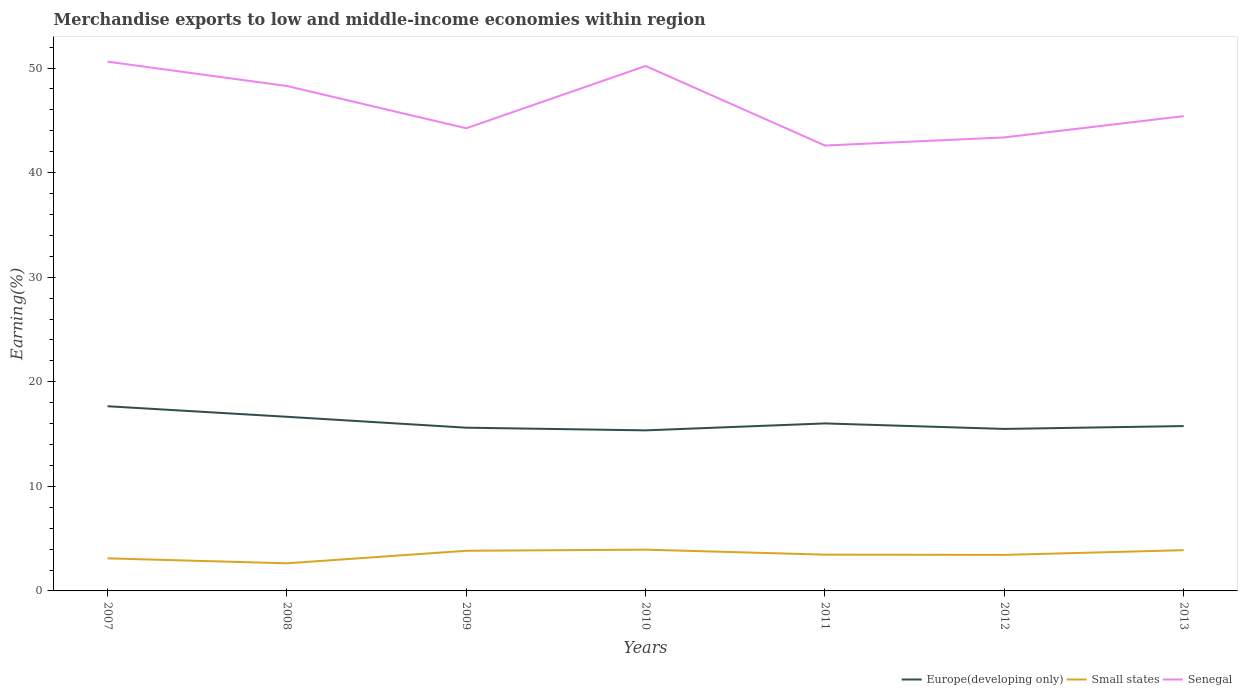How many different coloured lines are there?
Offer a very short reply. 3. Is the number of lines equal to the number of legend labels?
Your answer should be very brief. Yes. Across all years, what is the maximum percentage of amount earned from merchandise exports in Europe(developing only)?
Your answer should be very brief. 15.35. What is the total percentage of amount earned from merchandise exports in Senegal in the graph?
Offer a very short reply. 2.33. What is the difference between the highest and the second highest percentage of amount earned from merchandise exports in Europe(developing only)?
Offer a very short reply. 2.31. What is the difference between the highest and the lowest percentage of amount earned from merchandise exports in Small states?
Provide a succinct answer. 3. Is the percentage of amount earned from merchandise exports in Small states strictly greater than the percentage of amount earned from merchandise exports in Europe(developing only) over the years?
Give a very brief answer. Yes. How many lines are there?
Give a very brief answer. 3. How many years are there in the graph?
Provide a succinct answer. 7. Are the values on the major ticks of Y-axis written in scientific E-notation?
Provide a short and direct response. No. How many legend labels are there?
Give a very brief answer. 3. What is the title of the graph?
Your answer should be very brief. Merchandise exports to low and middle-income economies within region. What is the label or title of the X-axis?
Your answer should be compact. Years. What is the label or title of the Y-axis?
Make the answer very short. Earning(%). What is the Earning(%) in Europe(developing only) in 2007?
Your answer should be very brief. 17.66. What is the Earning(%) in Small states in 2007?
Ensure brevity in your answer.  3.12. What is the Earning(%) in Senegal in 2007?
Your answer should be compact. 50.61. What is the Earning(%) in Europe(developing only) in 2008?
Your response must be concise. 16.65. What is the Earning(%) of Small states in 2008?
Make the answer very short. 2.64. What is the Earning(%) in Senegal in 2008?
Your answer should be compact. 48.29. What is the Earning(%) of Europe(developing only) in 2009?
Your answer should be compact. 15.61. What is the Earning(%) of Small states in 2009?
Make the answer very short. 3.84. What is the Earning(%) of Senegal in 2009?
Ensure brevity in your answer.  44.24. What is the Earning(%) of Europe(developing only) in 2010?
Ensure brevity in your answer.  15.35. What is the Earning(%) of Small states in 2010?
Give a very brief answer. 3.95. What is the Earning(%) in Senegal in 2010?
Give a very brief answer. 50.2. What is the Earning(%) in Europe(developing only) in 2011?
Offer a terse response. 16.02. What is the Earning(%) in Small states in 2011?
Give a very brief answer. 3.47. What is the Earning(%) of Senegal in 2011?
Your answer should be very brief. 42.59. What is the Earning(%) in Europe(developing only) in 2012?
Your answer should be compact. 15.49. What is the Earning(%) in Small states in 2012?
Offer a very short reply. 3.45. What is the Earning(%) of Senegal in 2012?
Your answer should be very brief. 43.37. What is the Earning(%) in Europe(developing only) in 2013?
Your answer should be very brief. 15.77. What is the Earning(%) in Small states in 2013?
Ensure brevity in your answer.  3.9. What is the Earning(%) in Senegal in 2013?
Your response must be concise. 45.4. Across all years, what is the maximum Earning(%) of Europe(developing only)?
Keep it short and to the point. 17.66. Across all years, what is the maximum Earning(%) of Small states?
Provide a short and direct response. 3.95. Across all years, what is the maximum Earning(%) of Senegal?
Ensure brevity in your answer.  50.61. Across all years, what is the minimum Earning(%) in Europe(developing only)?
Your answer should be compact. 15.35. Across all years, what is the minimum Earning(%) of Small states?
Offer a terse response. 2.64. Across all years, what is the minimum Earning(%) in Senegal?
Your response must be concise. 42.59. What is the total Earning(%) in Europe(developing only) in the graph?
Provide a succinct answer. 112.55. What is the total Earning(%) of Small states in the graph?
Your answer should be very brief. 24.35. What is the total Earning(%) of Senegal in the graph?
Provide a succinct answer. 324.71. What is the difference between the Earning(%) of Europe(developing only) in 2007 and that in 2008?
Ensure brevity in your answer.  1.01. What is the difference between the Earning(%) in Small states in 2007 and that in 2008?
Keep it short and to the point. 0.48. What is the difference between the Earning(%) of Senegal in 2007 and that in 2008?
Give a very brief answer. 2.33. What is the difference between the Earning(%) of Europe(developing only) in 2007 and that in 2009?
Offer a very short reply. 2.05. What is the difference between the Earning(%) in Small states in 2007 and that in 2009?
Your answer should be very brief. -0.72. What is the difference between the Earning(%) in Senegal in 2007 and that in 2009?
Provide a succinct answer. 6.37. What is the difference between the Earning(%) of Europe(developing only) in 2007 and that in 2010?
Make the answer very short. 2.31. What is the difference between the Earning(%) in Small states in 2007 and that in 2010?
Provide a short and direct response. -0.83. What is the difference between the Earning(%) of Senegal in 2007 and that in 2010?
Offer a very short reply. 0.41. What is the difference between the Earning(%) in Europe(developing only) in 2007 and that in 2011?
Offer a very short reply. 1.64. What is the difference between the Earning(%) in Small states in 2007 and that in 2011?
Provide a succinct answer. -0.35. What is the difference between the Earning(%) in Senegal in 2007 and that in 2011?
Your response must be concise. 8.02. What is the difference between the Earning(%) in Europe(developing only) in 2007 and that in 2012?
Your answer should be compact. 2.17. What is the difference between the Earning(%) of Small states in 2007 and that in 2012?
Offer a terse response. -0.33. What is the difference between the Earning(%) in Senegal in 2007 and that in 2012?
Ensure brevity in your answer.  7.24. What is the difference between the Earning(%) in Europe(developing only) in 2007 and that in 2013?
Offer a very short reply. 1.9. What is the difference between the Earning(%) of Small states in 2007 and that in 2013?
Keep it short and to the point. -0.78. What is the difference between the Earning(%) of Senegal in 2007 and that in 2013?
Your response must be concise. 5.21. What is the difference between the Earning(%) of Europe(developing only) in 2008 and that in 2009?
Offer a terse response. 1.04. What is the difference between the Earning(%) in Small states in 2008 and that in 2009?
Your response must be concise. -1.2. What is the difference between the Earning(%) in Senegal in 2008 and that in 2009?
Provide a short and direct response. 4.04. What is the difference between the Earning(%) in Europe(developing only) in 2008 and that in 2010?
Your answer should be compact. 1.3. What is the difference between the Earning(%) in Small states in 2008 and that in 2010?
Keep it short and to the point. -1.31. What is the difference between the Earning(%) in Senegal in 2008 and that in 2010?
Your answer should be compact. -1.91. What is the difference between the Earning(%) of Europe(developing only) in 2008 and that in 2011?
Keep it short and to the point. 0.63. What is the difference between the Earning(%) in Small states in 2008 and that in 2011?
Your response must be concise. -0.83. What is the difference between the Earning(%) of Senegal in 2008 and that in 2011?
Give a very brief answer. 5.69. What is the difference between the Earning(%) of Europe(developing only) in 2008 and that in 2012?
Offer a terse response. 1.16. What is the difference between the Earning(%) in Small states in 2008 and that in 2012?
Provide a succinct answer. -0.81. What is the difference between the Earning(%) in Senegal in 2008 and that in 2012?
Make the answer very short. 4.92. What is the difference between the Earning(%) in Europe(developing only) in 2008 and that in 2013?
Your answer should be very brief. 0.89. What is the difference between the Earning(%) of Small states in 2008 and that in 2013?
Provide a succinct answer. -1.26. What is the difference between the Earning(%) in Senegal in 2008 and that in 2013?
Ensure brevity in your answer.  2.88. What is the difference between the Earning(%) in Europe(developing only) in 2009 and that in 2010?
Offer a very short reply. 0.26. What is the difference between the Earning(%) in Small states in 2009 and that in 2010?
Provide a short and direct response. -0.11. What is the difference between the Earning(%) in Senegal in 2009 and that in 2010?
Ensure brevity in your answer.  -5.96. What is the difference between the Earning(%) in Europe(developing only) in 2009 and that in 2011?
Make the answer very short. -0.41. What is the difference between the Earning(%) of Small states in 2009 and that in 2011?
Offer a very short reply. 0.37. What is the difference between the Earning(%) of Senegal in 2009 and that in 2011?
Give a very brief answer. 1.65. What is the difference between the Earning(%) in Europe(developing only) in 2009 and that in 2012?
Make the answer very short. 0.12. What is the difference between the Earning(%) in Small states in 2009 and that in 2012?
Your response must be concise. 0.39. What is the difference between the Earning(%) of Senegal in 2009 and that in 2012?
Offer a very short reply. 0.87. What is the difference between the Earning(%) of Europe(developing only) in 2009 and that in 2013?
Keep it short and to the point. -0.16. What is the difference between the Earning(%) in Small states in 2009 and that in 2013?
Offer a terse response. -0.06. What is the difference between the Earning(%) in Senegal in 2009 and that in 2013?
Give a very brief answer. -1.16. What is the difference between the Earning(%) of Europe(developing only) in 2010 and that in 2011?
Provide a short and direct response. -0.66. What is the difference between the Earning(%) in Small states in 2010 and that in 2011?
Provide a succinct answer. 0.48. What is the difference between the Earning(%) in Senegal in 2010 and that in 2011?
Keep it short and to the point. 7.61. What is the difference between the Earning(%) in Europe(developing only) in 2010 and that in 2012?
Provide a short and direct response. -0.14. What is the difference between the Earning(%) in Small states in 2010 and that in 2012?
Keep it short and to the point. 0.5. What is the difference between the Earning(%) of Senegal in 2010 and that in 2012?
Offer a terse response. 6.83. What is the difference between the Earning(%) in Europe(developing only) in 2010 and that in 2013?
Provide a short and direct response. -0.41. What is the difference between the Earning(%) in Small states in 2010 and that in 2013?
Ensure brevity in your answer.  0.05. What is the difference between the Earning(%) in Senegal in 2010 and that in 2013?
Give a very brief answer. 4.8. What is the difference between the Earning(%) of Europe(developing only) in 2011 and that in 2012?
Your answer should be compact. 0.53. What is the difference between the Earning(%) of Small states in 2011 and that in 2012?
Provide a succinct answer. 0.02. What is the difference between the Earning(%) of Senegal in 2011 and that in 2012?
Offer a terse response. -0.78. What is the difference between the Earning(%) in Europe(developing only) in 2011 and that in 2013?
Make the answer very short. 0.25. What is the difference between the Earning(%) of Small states in 2011 and that in 2013?
Give a very brief answer. -0.43. What is the difference between the Earning(%) in Senegal in 2011 and that in 2013?
Your response must be concise. -2.81. What is the difference between the Earning(%) of Europe(developing only) in 2012 and that in 2013?
Your answer should be compact. -0.27. What is the difference between the Earning(%) in Small states in 2012 and that in 2013?
Your answer should be very brief. -0.45. What is the difference between the Earning(%) in Senegal in 2012 and that in 2013?
Ensure brevity in your answer.  -2.03. What is the difference between the Earning(%) of Europe(developing only) in 2007 and the Earning(%) of Small states in 2008?
Provide a short and direct response. 15.02. What is the difference between the Earning(%) of Europe(developing only) in 2007 and the Earning(%) of Senegal in 2008?
Make the answer very short. -30.62. What is the difference between the Earning(%) of Small states in 2007 and the Earning(%) of Senegal in 2008?
Offer a very short reply. -45.17. What is the difference between the Earning(%) of Europe(developing only) in 2007 and the Earning(%) of Small states in 2009?
Keep it short and to the point. 13.82. What is the difference between the Earning(%) of Europe(developing only) in 2007 and the Earning(%) of Senegal in 2009?
Provide a succinct answer. -26.58. What is the difference between the Earning(%) in Small states in 2007 and the Earning(%) in Senegal in 2009?
Your answer should be very brief. -41.13. What is the difference between the Earning(%) of Europe(developing only) in 2007 and the Earning(%) of Small states in 2010?
Keep it short and to the point. 13.71. What is the difference between the Earning(%) in Europe(developing only) in 2007 and the Earning(%) in Senegal in 2010?
Ensure brevity in your answer.  -32.54. What is the difference between the Earning(%) of Small states in 2007 and the Earning(%) of Senegal in 2010?
Ensure brevity in your answer.  -47.08. What is the difference between the Earning(%) in Europe(developing only) in 2007 and the Earning(%) in Small states in 2011?
Offer a terse response. 14.19. What is the difference between the Earning(%) in Europe(developing only) in 2007 and the Earning(%) in Senegal in 2011?
Your answer should be very brief. -24.93. What is the difference between the Earning(%) of Small states in 2007 and the Earning(%) of Senegal in 2011?
Your answer should be very brief. -39.48. What is the difference between the Earning(%) in Europe(developing only) in 2007 and the Earning(%) in Small states in 2012?
Provide a short and direct response. 14.21. What is the difference between the Earning(%) of Europe(developing only) in 2007 and the Earning(%) of Senegal in 2012?
Ensure brevity in your answer.  -25.71. What is the difference between the Earning(%) in Small states in 2007 and the Earning(%) in Senegal in 2012?
Give a very brief answer. -40.25. What is the difference between the Earning(%) in Europe(developing only) in 2007 and the Earning(%) in Small states in 2013?
Your answer should be very brief. 13.76. What is the difference between the Earning(%) of Europe(developing only) in 2007 and the Earning(%) of Senegal in 2013?
Offer a terse response. -27.74. What is the difference between the Earning(%) of Small states in 2007 and the Earning(%) of Senegal in 2013?
Ensure brevity in your answer.  -42.29. What is the difference between the Earning(%) in Europe(developing only) in 2008 and the Earning(%) in Small states in 2009?
Your response must be concise. 12.81. What is the difference between the Earning(%) of Europe(developing only) in 2008 and the Earning(%) of Senegal in 2009?
Offer a terse response. -27.59. What is the difference between the Earning(%) in Small states in 2008 and the Earning(%) in Senegal in 2009?
Provide a succinct answer. -41.6. What is the difference between the Earning(%) in Europe(developing only) in 2008 and the Earning(%) in Small states in 2010?
Your response must be concise. 12.71. What is the difference between the Earning(%) of Europe(developing only) in 2008 and the Earning(%) of Senegal in 2010?
Make the answer very short. -33.55. What is the difference between the Earning(%) in Small states in 2008 and the Earning(%) in Senegal in 2010?
Provide a short and direct response. -47.56. What is the difference between the Earning(%) in Europe(developing only) in 2008 and the Earning(%) in Small states in 2011?
Keep it short and to the point. 13.18. What is the difference between the Earning(%) in Europe(developing only) in 2008 and the Earning(%) in Senegal in 2011?
Offer a terse response. -25.94. What is the difference between the Earning(%) in Small states in 2008 and the Earning(%) in Senegal in 2011?
Offer a very short reply. -39.95. What is the difference between the Earning(%) in Europe(developing only) in 2008 and the Earning(%) in Small states in 2012?
Your answer should be compact. 13.21. What is the difference between the Earning(%) of Europe(developing only) in 2008 and the Earning(%) of Senegal in 2012?
Offer a very short reply. -26.72. What is the difference between the Earning(%) in Small states in 2008 and the Earning(%) in Senegal in 2012?
Your answer should be compact. -40.73. What is the difference between the Earning(%) of Europe(developing only) in 2008 and the Earning(%) of Small states in 2013?
Keep it short and to the point. 12.76. What is the difference between the Earning(%) in Europe(developing only) in 2008 and the Earning(%) in Senegal in 2013?
Make the answer very short. -28.75. What is the difference between the Earning(%) in Small states in 2008 and the Earning(%) in Senegal in 2013?
Offer a very short reply. -42.76. What is the difference between the Earning(%) in Europe(developing only) in 2009 and the Earning(%) in Small states in 2010?
Offer a very short reply. 11.66. What is the difference between the Earning(%) in Europe(developing only) in 2009 and the Earning(%) in Senegal in 2010?
Ensure brevity in your answer.  -34.59. What is the difference between the Earning(%) of Small states in 2009 and the Earning(%) of Senegal in 2010?
Offer a very short reply. -46.36. What is the difference between the Earning(%) in Europe(developing only) in 2009 and the Earning(%) in Small states in 2011?
Keep it short and to the point. 12.14. What is the difference between the Earning(%) of Europe(developing only) in 2009 and the Earning(%) of Senegal in 2011?
Keep it short and to the point. -26.98. What is the difference between the Earning(%) in Small states in 2009 and the Earning(%) in Senegal in 2011?
Your response must be concise. -38.76. What is the difference between the Earning(%) in Europe(developing only) in 2009 and the Earning(%) in Small states in 2012?
Provide a short and direct response. 12.16. What is the difference between the Earning(%) of Europe(developing only) in 2009 and the Earning(%) of Senegal in 2012?
Offer a terse response. -27.76. What is the difference between the Earning(%) of Small states in 2009 and the Earning(%) of Senegal in 2012?
Give a very brief answer. -39.53. What is the difference between the Earning(%) of Europe(developing only) in 2009 and the Earning(%) of Small states in 2013?
Offer a very short reply. 11.71. What is the difference between the Earning(%) in Europe(developing only) in 2009 and the Earning(%) in Senegal in 2013?
Your answer should be compact. -29.79. What is the difference between the Earning(%) of Small states in 2009 and the Earning(%) of Senegal in 2013?
Ensure brevity in your answer.  -41.56. What is the difference between the Earning(%) of Europe(developing only) in 2010 and the Earning(%) of Small states in 2011?
Make the answer very short. 11.89. What is the difference between the Earning(%) in Europe(developing only) in 2010 and the Earning(%) in Senegal in 2011?
Offer a very short reply. -27.24. What is the difference between the Earning(%) in Small states in 2010 and the Earning(%) in Senegal in 2011?
Keep it short and to the point. -38.65. What is the difference between the Earning(%) of Europe(developing only) in 2010 and the Earning(%) of Small states in 2012?
Ensure brevity in your answer.  11.91. What is the difference between the Earning(%) in Europe(developing only) in 2010 and the Earning(%) in Senegal in 2012?
Ensure brevity in your answer.  -28.02. What is the difference between the Earning(%) of Small states in 2010 and the Earning(%) of Senegal in 2012?
Offer a terse response. -39.42. What is the difference between the Earning(%) in Europe(developing only) in 2010 and the Earning(%) in Small states in 2013?
Your answer should be compact. 11.46. What is the difference between the Earning(%) of Europe(developing only) in 2010 and the Earning(%) of Senegal in 2013?
Give a very brief answer. -30.05. What is the difference between the Earning(%) in Small states in 2010 and the Earning(%) in Senegal in 2013?
Provide a succinct answer. -41.46. What is the difference between the Earning(%) of Europe(developing only) in 2011 and the Earning(%) of Small states in 2012?
Your response must be concise. 12.57. What is the difference between the Earning(%) of Europe(developing only) in 2011 and the Earning(%) of Senegal in 2012?
Make the answer very short. -27.35. What is the difference between the Earning(%) of Small states in 2011 and the Earning(%) of Senegal in 2012?
Make the answer very short. -39.9. What is the difference between the Earning(%) of Europe(developing only) in 2011 and the Earning(%) of Small states in 2013?
Provide a succinct answer. 12.12. What is the difference between the Earning(%) in Europe(developing only) in 2011 and the Earning(%) in Senegal in 2013?
Ensure brevity in your answer.  -29.39. What is the difference between the Earning(%) in Small states in 2011 and the Earning(%) in Senegal in 2013?
Keep it short and to the point. -41.94. What is the difference between the Earning(%) of Europe(developing only) in 2012 and the Earning(%) of Small states in 2013?
Your answer should be very brief. 11.6. What is the difference between the Earning(%) of Europe(developing only) in 2012 and the Earning(%) of Senegal in 2013?
Your response must be concise. -29.91. What is the difference between the Earning(%) in Small states in 2012 and the Earning(%) in Senegal in 2013?
Your answer should be very brief. -41.96. What is the average Earning(%) of Europe(developing only) per year?
Provide a short and direct response. 16.08. What is the average Earning(%) of Small states per year?
Provide a short and direct response. 3.48. What is the average Earning(%) in Senegal per year?
Offer a terse response. 46.39. In the year 2007, what is the difference between the Earning(%) of Europe(developing only) and Earning(%) of Small states?
Your response must be concise. 14.55. In the year 2007, what is the difference between the Earning(%) of Europe(developing only) and Earning(%) of Senegal?
Keep it short and to the point. -32.95. In the year 2007, what is the difference between the Earning(%) of Small states and Earning(%) of Senegal?
Your answer should be compact. -47.5. In the year 2008, what is the difference between the Earning(%) of Europe(developing only) and Earning(%) of Small states?
Make the answer very short. 14.01. In the year 2008, what is the difference between the Earning(%) in Europe(developing only) and Earning(%) in Senegal?
Your response must be concise. -31.63. In the year 2008, what is the difference between the Earning(%) in Small states and Earning(%) in Senegal?
Provide a succinct answer. -45.65. In the year 2009, what is the difference between the Earning(%) in Europe(developing only) and Earning(%) in Small states?
Your answer should be very brief. 11.77. In the year 2009, what is the difference between the Earning(%) in Europe(developing only) and Earning(%) in Senegal?
Your answer should be very brief. -28.63. In the year 2009, what is the difference between the Earning(%) in Small states and Earning(%) in Senegal?
Your answer should be very brief. -40.4. In the year 2010, what is the difference between the Earning(%) of Europe(developing only) and Earning(%) of Small states?
Your answer should be very brief. 11.41. In the year 2010, what is the difference between the Earning(%) of Europe(developing only) and Earning(%) of Senegal?
Give a very brief answer. -34.84. In the year 2010, what is the difference between the Earning(%) in Small states and Earning(%) in Senegal?
Give a very brief answer. -46.25. In the year 2011, what is the difference between the Earning(%) in Europe(developing only) and Earning(%) in Small states?
Ensure brevity in your answer.  12.55. In the year 2011, what is the difference between the Earning(%) of Europe(developing only) and Earning(%) of Senegal?
Your answer should be compact. -26.57. In the year 2011, what is the difference between the Earning(%) in Small states and Earning(%) in Senegal?
Ensure brevity in your answer.  -39.12. In the year 2012, what is the difference between the Earning(%) of Europe(developing only) and Earning(%) of Small states?
Offer a very short reply. 12.05. In the year 2012, what is the difference between the Earning(%) in Europe(developing only) and Earning(%) in Senegal?
Offer a very short reply. -27.88. In the year 2012, what is the difference between the Earning(%) of Small states and Earning(%) of Senegal?
Ensure brevity in your answer.  -39.92. In the year 2013, what is the difference between the Earning(%) in Europe(developing only) and Earning(%) in Small states?
Ensure brevity in your answer.  11.87. In the year 2013, what is the difference between the Earning(%) in Europe(developing only) and Earning(%) in Senegal?
Make the answer very short. -29.64. In the year 2013, what is the difference between the Earning(%) of Small states and Earning(%) of Senegal?
Your answer should be compact. -41.51. What is the ratio of the Earning(%) in Europe(developing only) in 2007 to that in 2008?
Your response must be concise. 1.06. What is the ratio of the Earning(%) of Small states in 2007 to that in 2008?
Provide a short and direct response. 1.18. What is the ratio of the Earning(%) in Senegal in 2007 to that in 2008?
Give a very brief answer. 1.05. What is the ratio of the Earning(%) in Europe(developing only) in 2007 to that in 2009?
Provide a short and direct response. 1.13. What is the ratio of the Earning(%) in Small states in 2007 to that in 2009?
Your answer should be compact. 0.81. What is the ratio of the Earning(%) in Senegal in 2007 to that in 2009?
Offer a very short reply. 1.14. What is the ratio of the Earning(%) in Europe(developing only) in 2007 to that in 2010?
Provide a short and direct response. 1.15. What is the ratio of the Earning(%) of Small states in 2007 to that in 2010?
Offer a very short reply. 0.79. What is the ratio of the Earning(%) of Senegal in 2007 to that in 2010?
Provide a short and direct response. 1.01. What is the ratio of the Earning(%) in Europe(developing only) in 2007 to that in 2011?
Ensure brevity in your answer.  1.1. What is the ratio of the Earning(%) in Small states in 2007 to that in 2011?
Ensure brevity in your answer.  0.9. What is the ratio of the Earning(%) in Senegal in 2007 to that in 2011?
Your answer should be compact. 1.19. What is the ratio of the Earning(%) in Europe(developing only) in 2007 to that in 2012?
Give a very brief answer. 1.14. What is the ratio of the Earning(%) in Small states in 2007 to that in 2012?
Your response must be concise. 0.9. What is the ratio of the Earning(%) in Senegal in 2007 to that in 2012?
Offer a terse response. 1.17. What is the ratio of the Earning(%) of Europe(developing only) in 2007 to that in 2013?
Provide a short and direct response. 1.12. What is the ratio of the Earning(%) in Small states in 2007 to that in 2013?
Give a very brief answer. 0.8. What is the ratio of the Earning(%) in Senegal in 2007 to that in 2013?
Your answer should be very brief. 1.11. What is the ratio of the Earning(%) in Europe(developing only) in 2008 to that in 2009?
Provide a short and direct response. 1.07. What is the ratio of the Earning(%) of Small states in 2008 to that in 2009?
Provide a short and direct response. 0.69. What is the ratio of the Earning(%) in Senegal in 2008 to that in 2009?
Provide a succinct answer. 1.09. What is the ratio of the Earning(%) of Europe(developing only) in 2008 to that in 2010?
Ensure brevity in your answer.  1.08. What is the ratio of the Earning(%) of Small states in 2008 to that in 2010?
Your response must be concise. 0.67. What is the ratio of the Earning(%) of Senegal in 2008 to that in 2010?
Keep it short and to the point. 0.96. What is the ratio of the Earning(%) in Europe(developing only) in 2008 to that in 2011?
Offer a terse response. 1.04. What is the ratio of the Earning(%) of Small states in 2008 to that in 2011?
Make the answer very short. 0.76. What is the ratio of the Earning(%) in Senegal in 2008 to that in 2011?
Ensure brevity in your answer.  1.13. What is the ratio of the Earning(%) of Europe(developing only) in 2008 to that in 2012?
Offer a terse response. 1.07. What is the ratio of the Earning(%) in Small states in 2008 to that in 2012?
Provide a succinct answer. 0.77. What is the ratio of the Earning(%) of Senegal in 2008 to that in 2012?
Your answer should be very brief. 1.11. What is the ratio of the Earning(%) in Europe(developing only) in 2008 to that in 2013?
Offer a very short reply. 1.06. What is the ratio of the Earning(%) of Small states in 2008 to that in 2013?
Offer a very short reply. 0.68. What is the ratio of the Earning(%) in Senegal in 2008 to that in 2013?
Offer a very short reply. 1.06. What is the ratio of the Earning(%) in Europe(developing only) in 2009 to that in 2010?
Offer a very short reply. 1.02. What is the ratio of the Earning(%) in Small states in 2009 to that in 2010?
Make the answer very short. 0.97. What is the ratio of the Earning(%) of Senegal in 2009 to that in 2010?
Provide a short and direct response. 0.88. What is the ratio of the Earning(%) in Europe(developing only) in 2009 to that in 2011?
Your response must be concise. 0.97. What is the ratio of the Earning(%) of Small states in 2009 to that in 2011?
Make the answer very short. 1.11. What is the ratio of the Earning(%) of Senegal in 2009 to that in 2011?
Ensure brevity in your answer.  1.04. What is the ratio of the Earning(%) of Europe(developing only) in 2009 to that in 2012?
Make the answer very short. 1.01. What is the ratio of the Earning(%) in Small states in 2009 to that in 2012?
Your answer should be very brief. 1.11. What is the ratio of the Earning(%) in Senegal in 2009 to that in 2012?
Give a very brief answer. 1.02. What is the ratio of the Earning(%) in Senegal in 2009 to that in 2013?
Make the answer very short. 0.97. What is the ratio of the Earning(%) in Europe(developing only) in 2010 to that in 2011?
Ensure brevity in your answer.  0.96. What is the ratio of the Earning(%) of Small states in 2010 to that in 2011?
Give a very brief answer. 1.14. What is the ratio of the Earning(%) in Senegal in 2010 to that in 2011?
Your answer should be compact. 1.18. What is the ratio of the Earning(%) in Europe(developing only) in 2010 to that in 2012?
Offer a very short reply. 0.99. What is the ratio of the Earning(%) in Small states in 2010 to that in 2012?
Your answer should be compact. 1.15. What is the ratio of the Earning(%) in Senegal in 2010 to that in 2012?
Your response must be concise. 1.16. What is the ratio of the Earning(%) in Europe(developing only) in 2010 to that in 2013?
Your answer should be compact. 0.97. What is the ratio of the Earning(%) of Small states in 2010 to that in 2013?
Keep it short and to the point. 1.01. What is the ratio of the Earning(%) of Senegal in 2010 to that in 2013?
Provide a succinct answer. 1.11. What is the ratio of the Earning(%) in Europe(developing only) in 2011 to that in 2012?
Offer a terse response. 1.03. What is the ratio of the Earning(%) of Small states in 2011 to that in 2012?
Offer a very short reply. 1.01. What is the ratio of the Earning(%) of Senegal in 2011 to that in 2012?
Provide a short and direct response. 0.98. What is the ratio of the Earning(%) of Small states in 2011 to that in 2013?
Offer a terse response. 0.89. What is the ratio of the Earning(%) in Senegal in 2011 to that in 2013?
Provide a succinct answer. 0.94. What is the ratio of the Earning(%) in Europe(developing only) in 2012 to that in 2013?
Ensure brevity in your answer.  0.98. What is the ratio of the Earning(%) of Small states in 2012 to that in 2013?
Keep it short and to the point. 0.88. What is the ratio of the Earning(%) in Senegal in 2012 to that in 2013?
Offer a very short reply. 0.96. What is the difference between the highest and the second highest Earning(%) of Europe(developing only)?
Make the answer very short. 1.01. What is the difference between the highest and the second highest Earning(%) of Small states?
Your answer should be very brief. 0.05. What is the difference between the highest and the second highest Earning(%) in Senegal?
Offer a terse response. 0.41. What is the difference between the highest and the lowest Earning(%) in Europe(developing only)?
Provide a succinct answer. 2.31. What is the difference between the highest and the lowest Earning(%) in Small states?
Provide a succinct answer. 1.31. What is the difference between the highest and the lowest Earning(%) of Senegal?
Offer a very short reply. 8.02. 